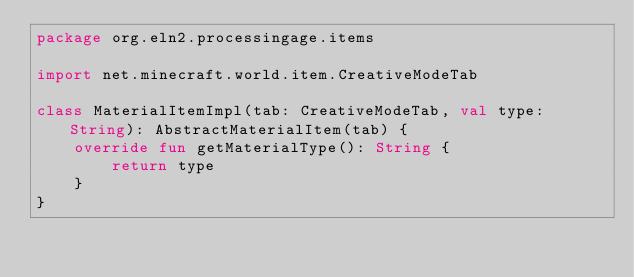<code> <loc_0><loc_0><loc_500><loc_500><_Kotlin_>package org.eln2.processingage.items

import net.minecraft.world.item.CreativeModeTab

class MaterialItemImpl(tab: CreativeModeTab, val type: String): AbstractMaterialItem(tab) {
    override fun getMaterialType(): String {
        return type
    }
}
</code> 